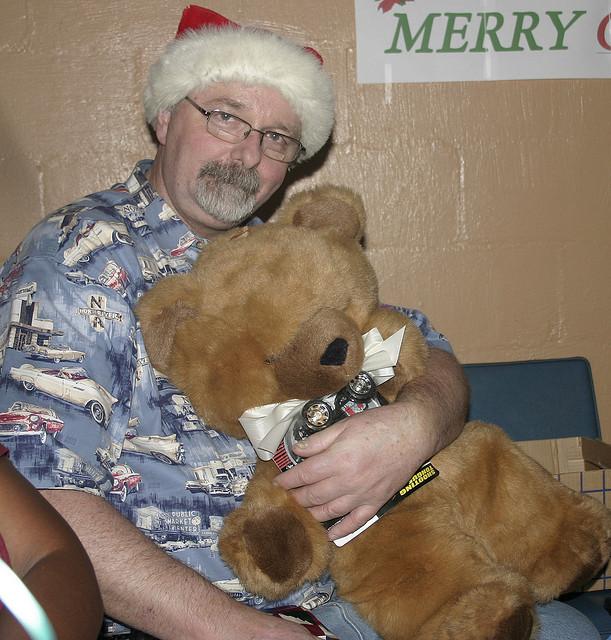How many arms are visible in this picture?
Short answer required. 3. Did the man get the teddy bear for Christmas?
Keep it brief. Yes. Does this man have facial hair?
Answer briefly. Yes. 